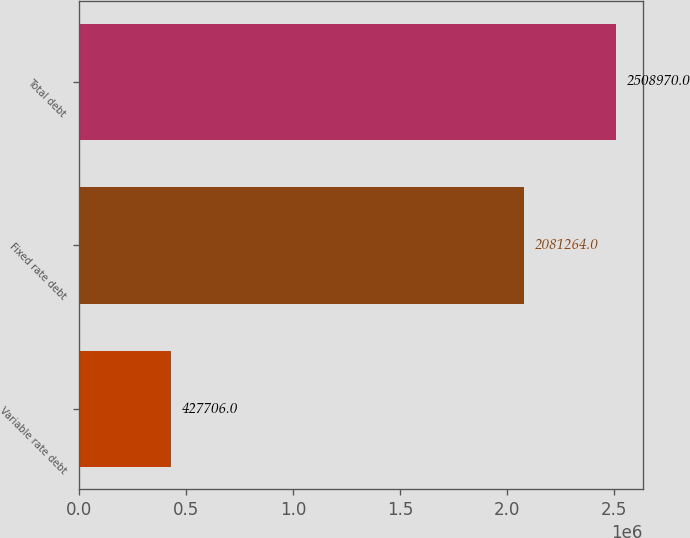<chart> <loc_0><loc_0><loc_500><loc_500><bar_chart><fcel>Variable rate debt<fcel>Fixed rate debt<fcel>Total debt<nl><fcel>427706<fcel>2.08126e+06<fcel>2.50897e+06<nl></chart> 